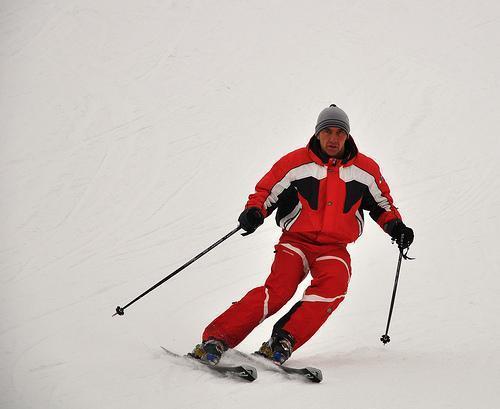How many people are in the picture?
Give a very brief answer. 1. 